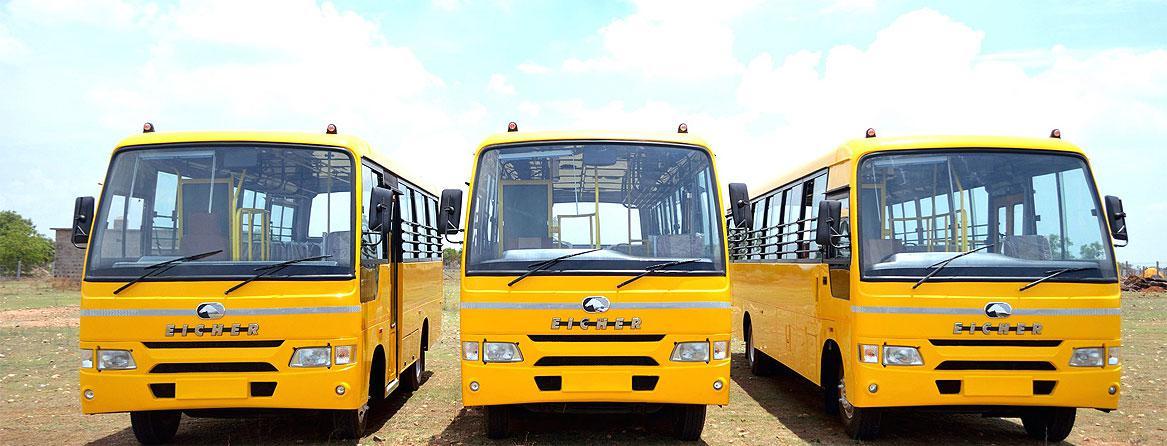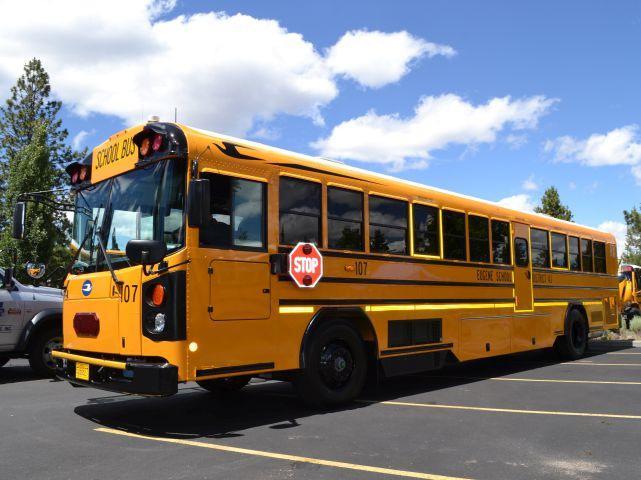The first image is the image on the left, the second image is the image on the right. Evaluate the accuracy of this statement regarding the images: "there is a yellow school bus with a flat front and the stop sign visible". Is it true? Answer yes or no. Yes. The first image is the image on the left, the second image is the image on the right. Considering the images on both sides, is "Each image shows a single yellow bus with a nearly flat front, and the bus on the right is displayed at an angle but does not have a black stripe visible on its side." valid? Answer yes or no. No. 